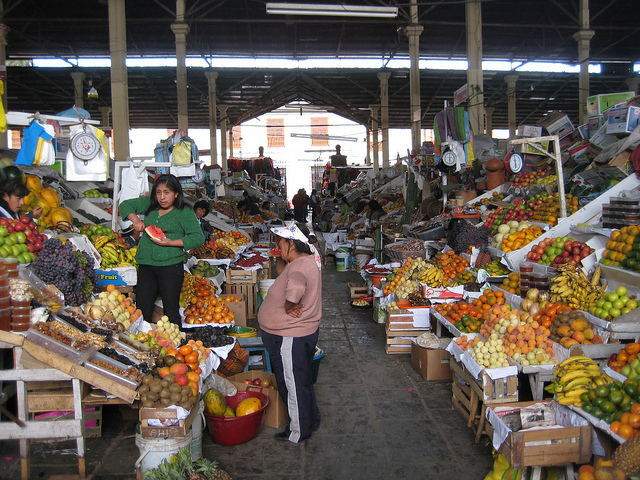What kinds of fruits can you see in this market? I can identify a rich variety of fruits, including bananas, oranges, apples, and what appears to be grapes. There are also some tropical fruits like pineapples and possibly mangoes amongst the colorful assortment. 